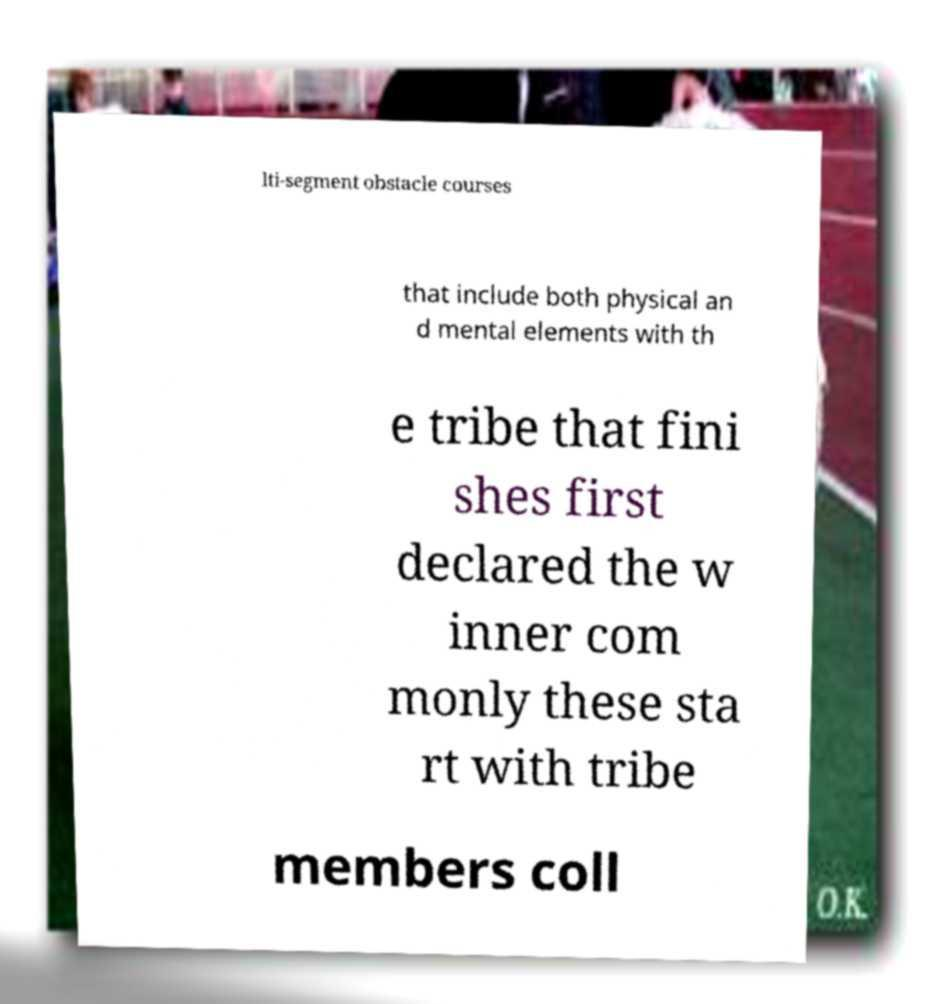Could you extract and type out the text from this image? lti-segment obstacle courses that include both physical an d mental elements with th e tribe that fini shes first declared the w inner com monly these sta rt with tribe members coll 